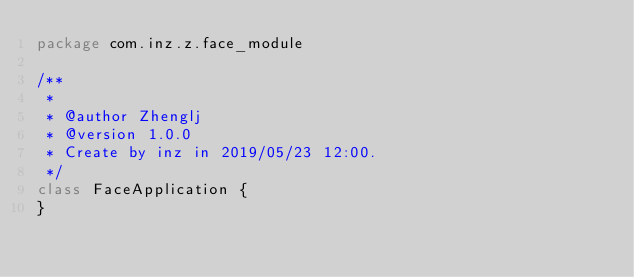Convert code to text. <code><loc_0><loc_0><loc_500><loc_500><_Kotlin_>package com.inz.z.face_module

/**
 *
 * @author Zhenglj
 * @version 1.0.0
 * Create by inz in 2019/05/23 12:00.
 */
class FaceApplication {
}</code> 